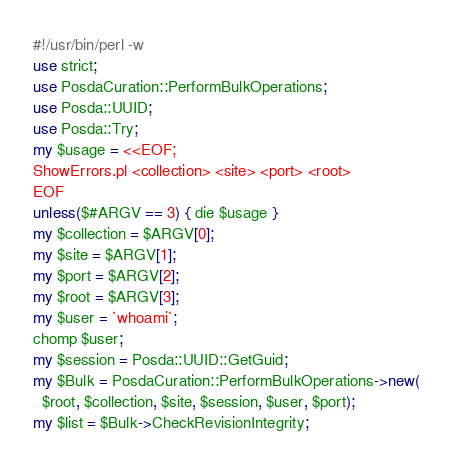Convert code to text. <code><loc_0><loc_0><loc_500><loc_500><_Perl_>#!/usr/bin/perl -w
use strict;
use PosdaCuration::PerformBulkOperations;
use Posda::UUID;
use Posda::Try;
my $usage = <<EOF;
ShowErrors.pl <collection> <site> <port> <root>
EOF
unless($#ARGV == 3) { die $usage }
my $collection = $ARGV[0];
my $site = $ARGV[1];
my $port = $ARGV[2];
my $root = $ARGV[3];
my $user = `whoami`;
chomp $user;
my $session = Posda::UUID::GetGuid;
my $Bulk = PosdaCuration::PerformBulkOperations->new(
  $root, $collection, $site, $session, $user, $port);
my $list = $Bulk->CheckRevisionIntegrity;
</code> 